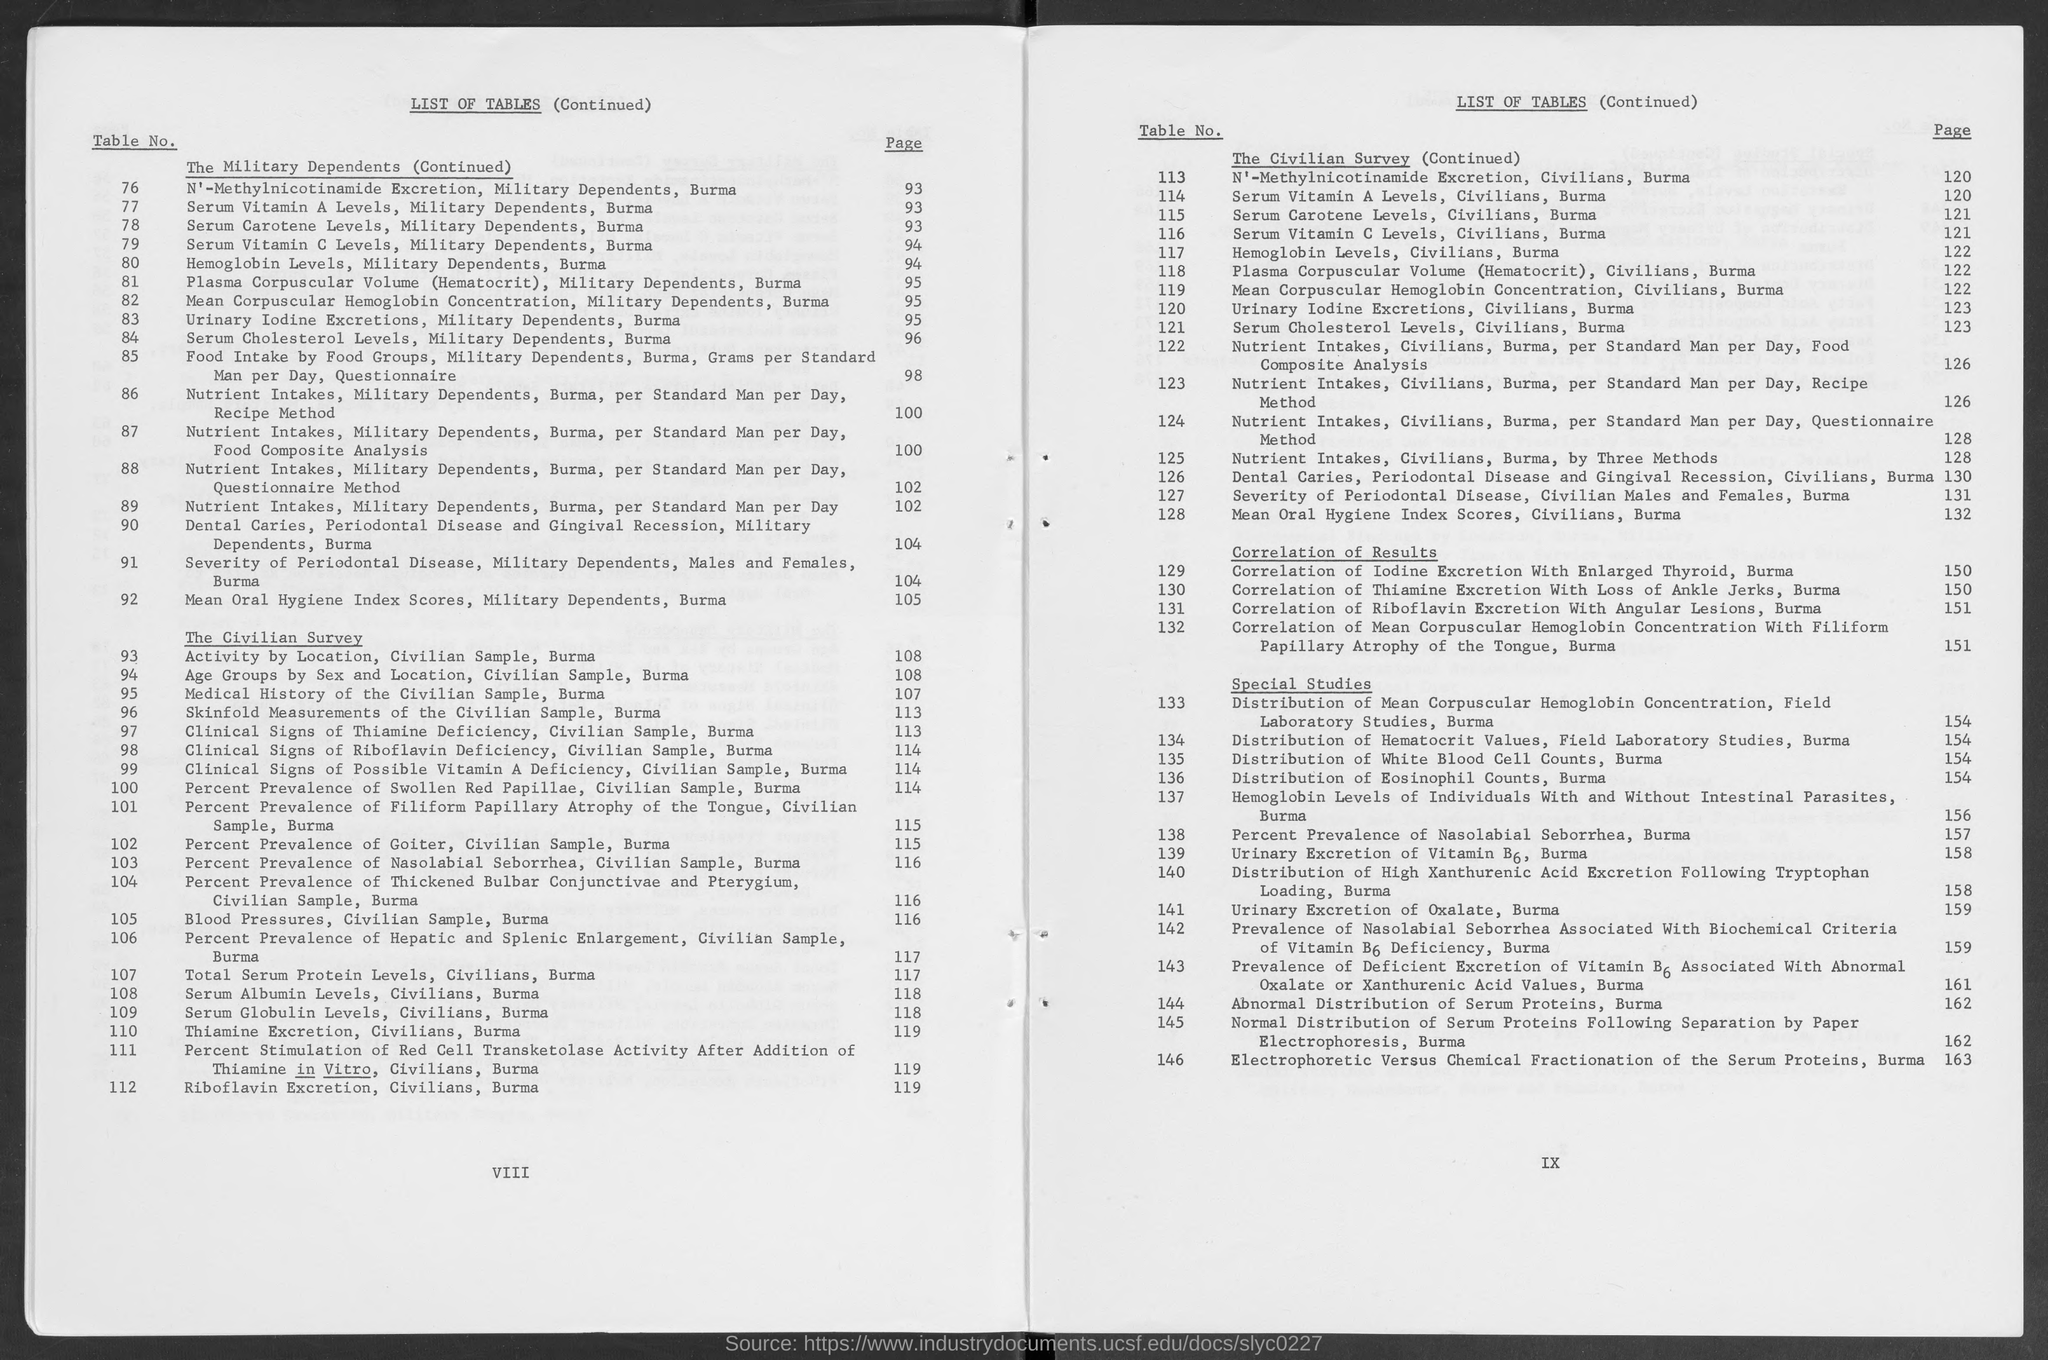What is the page number for table no. 113?
Your answer should be compact. 120. What is the page number for table no. 114  ?
Your answer should be compact. 120. What is the page number for table no. 115?
Your answer should be compact. 121. What is the page number for table no. 116?
Ensure brevity in your answer.  121. What is the page number for table no. 117?
Offer a very short reply. 122. What is the page number for table no.118?
Offer a very short reply. 122. What is the page number for table no. 119?
Offer a terse response. 122. What is the page number for table no. 120?
Provide a succinct answer. 123. What is the page number for table no. 121?
Offer a very short reply. 123. What is the page number for table no. 122?
Ensure brevity in your answer.  126. 